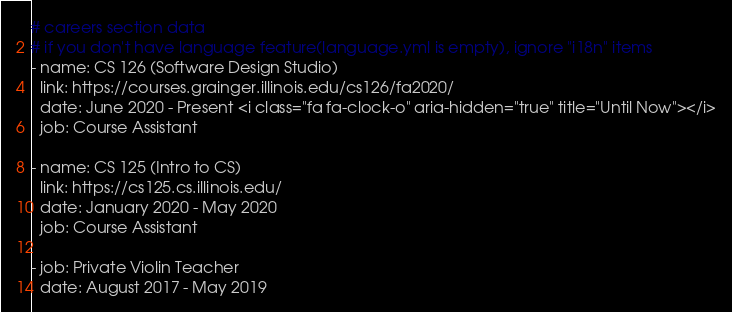Convert code to text. <code><loc_0><loc_0><loc_500><loc_500><_YAML_># careers section data
# if you don't have language feature(language.yml is empty), ignore "i18n" items
- name: CS 126 (Software Design Studio) 
  link: https://courses.grainger.illinois.edu/cs126/fa2020/
  date: June 2020 - Present <i class="fa fa-clock-o" aria-hidden="true" title="Until Now"></i>
  job: Course Assistant
  
- name: CS 125 (Intro to CS)	
  link: https://cs125.cs.illinois.edu/
  date: January 2020 - May 2020
  job: Course Assistant

- job: Private Violin Teacher
  date: August 2017 - May 2019
</code> 